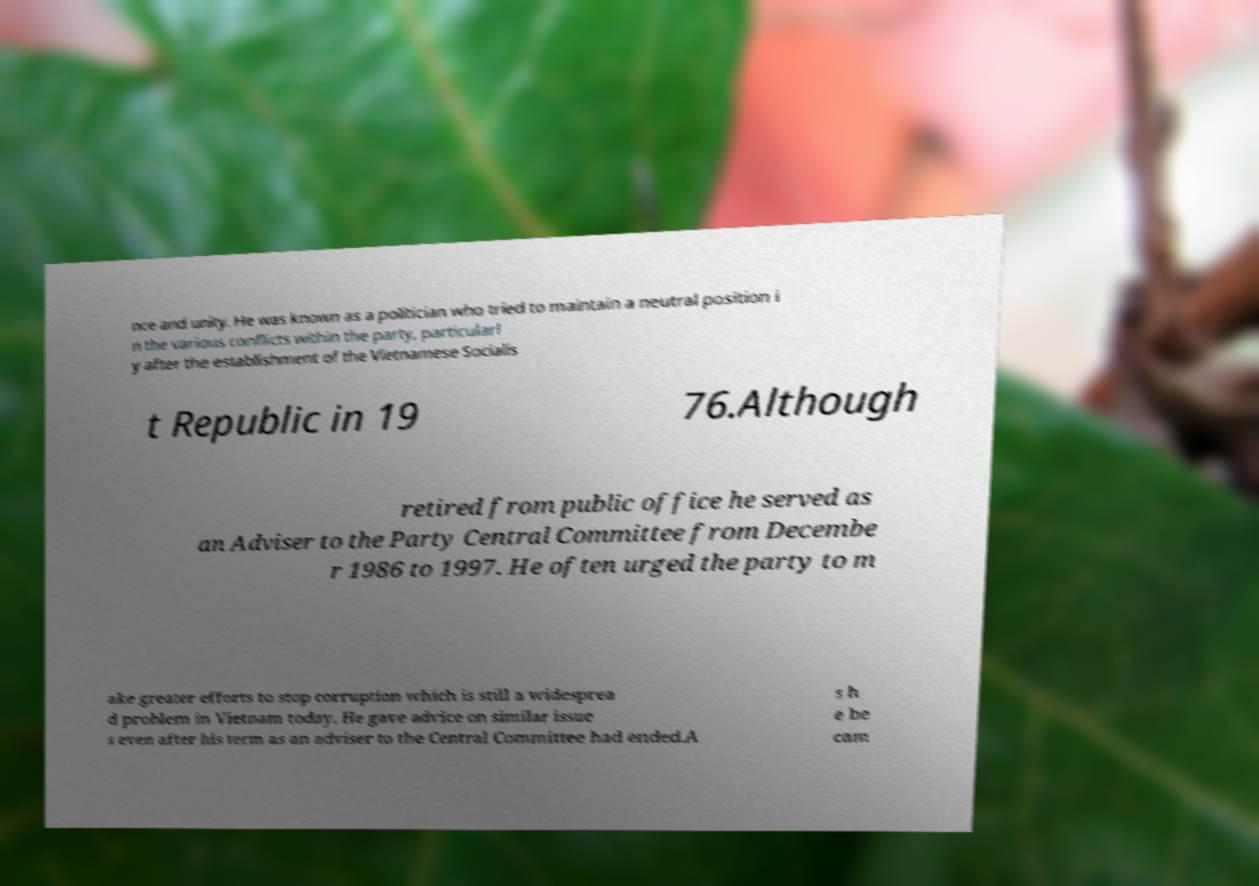Can you read and provide the text displayed in the image?This photo seems to have some interesting text. Can you extract and type it out for me? nce and unity. He was known as a politician who tried to maintain a neutral position i n the various conflicts within the party, particularl y after the establishment of the Vietnamese Socialis t Republic in 19 76.Although retired from public office he served as an Adviser to the Party Central Committee from Decembe r 1986 to 1997. He often urged the party to m ake greater efforts to stop corruption which is still a widesprea d problem in Vietnam today. He gave advice on similar issue s even after his term as an adviser to the Central Committee had ended.A s h e be cam 